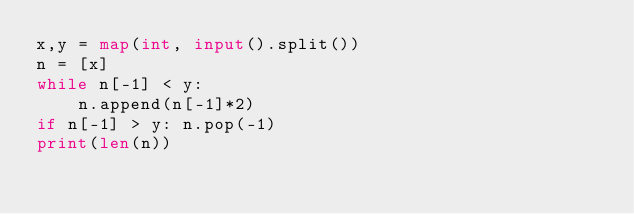Convert code to text. <code><loc_0><loc_0><loc_500><loc_500><_Python_>x,y = map(int, input().split())
n = [x]
while n[-1] < y:
    n.append(n[-1]*2)
if n[-1] > y: n.pop(-1)
print(len(n))</code> 